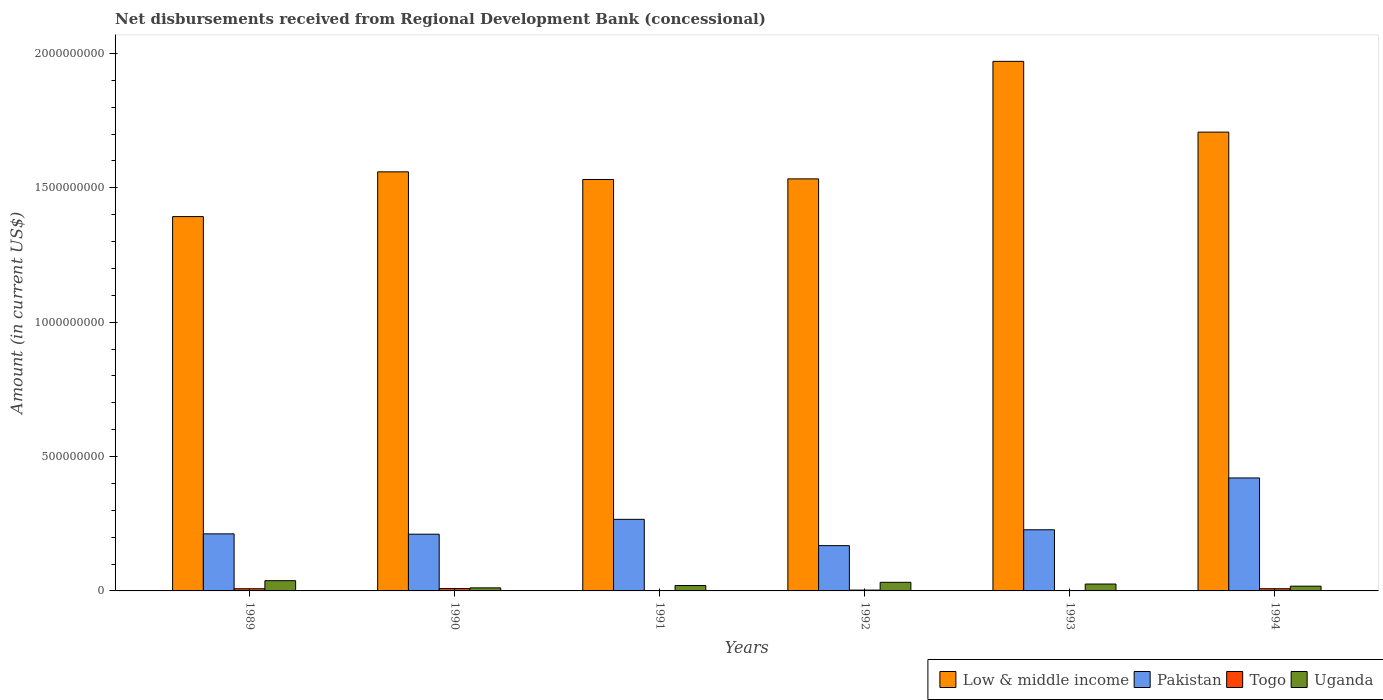How many different coloured bars are there?
Offer a terse response. 4. How many groups of bars are there?
Offer a terse response. 6. How many bars are there on the 2nd tick from the right?
Offer a very short reply. 4. What is the label of the 3rd group of bars from the left?
Offer a very short reply. 1991. In how many cases, is the number of bars for a given year not equal to the number of legend labels?
Keep it short and to the point. 0. What is the amount of disbursements received from Regional Development Bank in Togo in 1991?
Provide a succinct answer. 9.84e+05. Across all years, what is the maximum amount of disbursements received from Regional Development Bank in Uganda?
Ensure brevity in your answer.  3.81e+07. Across all years, what is the minimum amount of disbursements received from Regional Development Bank in Low & middle income?
Give a very brief answer. 1.39e+09. In which year was the amount of disbursements received from Regional Development Bank in Uganda minimum?
Your answer should be compact. 1990. What is the total amount of disbursements received from Regional Development Bank in Togo in the graph?
Provide a short and direct response. 2.90e+07. What is the difference between the amount of disbursements received from Regional Development Bank in Togo in 1989 and that in 1990?
Provide a succinct answer. -6.17e+05. What is the difference between the amount of disbursements received from Regional Development Bank in Low & middle income in 1994 and the amount of disbursements received from Regional Development Bank in Togo in 1990?
Keep it short and to the point. 1.70e+09. What is the average amount of disbursements received from Regional Development Bank in Togo per year?
Your answer should be compact. 4.84e+06. In the year 1989, what is the difference between the amount of disbursements received from Regional Development Bank in Togo and amount of disbursements received from Regional Development Bank in Uganda?
Your response must be concise. -3.01e+07. In how many years, is the amount of disbursements received from Regional Development Bank in Low & middle income greater than 1200000000 US$?
Your response must be concise. 6. What is the ratio of the amount of disbursements received from Regional Development Bank in Pakistan in 1989 to that in 1991?
Your answer should be very brief. 0.8. What is the difference between the highest and the second highest amount of disbursements received from Regional Development Bank in Uganda?
Make the answer very short. 6.10e+06. What is the difference between the highest and the lowest amount of disbursements received from Regional Development Bank in Pakistan?
Give a very brief answer. 2.52e+08. Is the sum of the amount of disbursements received from Regional Development Bank in Pakistan in 1989 and 1994 greater than the maximum amount of disbursements received from Regional Development Bank in Low & middle income across all years?
Give a very brief answer. No. Is it the case that in every year, the sum of the amount of disbursements received from Regional Development Bank in Togo and amount of disbursements received from Regional Development Bank in Pakistan is greater than the sum of amount of disbursements received from Regional Development Bank in Low & middle income and amount of disbursements received from Regional Development Bank in Uganda?
Give a very brief answer. Yes. What does the 4th bar from the right in 1993 represents?
Offer a terse response. Low & middle income. How many bars are there?
Keep it short and to the point. 24. How many years are there in the graph?
Offer a very short reply. 6. Does the graph contain any zero values?
Your response must be concise. No. Does the graph contain grids?
Offer a very short reply. No. How many legend labels are there?
Your response must be concise. 4. What is the title of the graph?
Offer a terse response. Net disbursements received from Regional Development Bank (concessional). Does "Greece" appear as one of the legend labels in the graph?
Your answer should be very brief. No. What is the label or title of the Y-axis?
Offer a very short reply. Amount (in current US$). What is the Amount (in current US$) in Low & middle income in 1989?
Your answer should be very brief. 1.39e+09. What is the Amount (in current US$) in Pakistan in 1989?
Keep it short and to the point. 2.12e+08. What is the Amount (in current US$) of Togo in 1989?
Make the answer very short. 8.07e+06. What is the Amount (in current US$) of Uganda in 1989?
Provide a short and direct response. 3.81e+07. What is the Amount (in current US$) in Low & middle income in 1990?
Keep it short and to the point. 1.56e+09. What is the Amount (in current US$) of Pakistan in 1990?
Offer a terse response. 2.11e+08. What is the Amount (in current US$) in Togo in 1990?
Your response must be concise. 8.69e+06. What is the Amount (in current US$) in Uganda in 1990?
Offer a very short reply. 1.14e+07. What is the Amount (in current US$) in Low & middle income in 1991?
Offer a terse response. 1.53e+09. What is the Amount (in current US$) of Pakistan in 1991?
Ensure brevity in your answer.  2.66e+08. What is the Amount (in current US$) of Togo in 1991?
Your answer should be very brief. 9.84e+05. What is the Amount (in current US$) of Uganda in 1991?
Give a very brief answer. 2.01e+07. What is the Amount (in current US$) of Low & middle income in 1992?
Make the answer very short. 1.53e+09. What is the Amount (in current US$) in Pakistan in 1992?
Your answer should be very brief. 1.69e+08. What is the Amount (in current US$) of Togo in 1992?
Your answer should be compact. 3.04e+06. What is the Amount (in current US$) in Uganda in 1992?
Give a very brief answer. 3.20e+07. What is the Amount (in current US$) of Low & middle income in 1993?
Provide a succinct answer. 1.97e+09. What is the Amount (in current US$) in Pakistan in 1993?
Your response must be concise. 2.28e+08. What is the Amount (in current US$) in Togo in 1993?
Your response must be concise. 8.80e+04. What is the Amount (in current US$) in Uganda in 1993?
Your answer should be compact. 2.56e+07. What is the Amount (in current US$) of Low & middle income in 1994?
Give a very brief answer. 1.71e+09. What is the Amount (in current US$) in Pakistan in 1994?
Make the answer very short. 4.20e+08. What is the Amount (in current US$) of Togo in 1994?
Provide a short and direct response. 8.16e+06. What is the Amount (in current US$) in Uganda in 1994?
Your answer should be very brief. 1.77e+07. Across all years, what is the maximum Amount (in current US$) in Low & middle income?
Provide a succinct answer. 1.97e+09. Across all years, what is the maximum Amount (in current US$) in Pakistan?
Ensure brevity in your answer.  4.20e+08. Across all years, what is the maximum Amount (in current US$) in Togo?
Your answer should be very brief. 8.69e+06. Across all years, what is the maximum Amount (in current US$) of Uganda?
Your answer should be compact. 3.81e+07. Across all years, what is the minimum Amount (in current US$) in Low & middle income?
Ensure brevity in your answer.  1.39e+09. Across all years, what is the minimum Amount (in current US$) of Pakistan?
Give a very brief answer. 1.69e+08. Across all years, what is the minimum Amount (in current US$) in Togo?
Your answer should be compact. 8.80e+04. Across all years, what is the minimum Amount (in current US$) of Uganda?
Give a very brief answer. 1.14e+07. What is the total Amount (in current US$) in Low & middle income in the graph?
Provide a short and direct response. 9.70e+09. What is the total Amount (in current US$) of Pakistan in the graph?
Provide a short and direct response. 1.51e+09. What is the total Amount (in current US$) in Togo in the graph?
Offer a very short reply. 2.90e+07. What is the total Amount (in current US$) of Uganda in the graph?
Offer a very short reply. 1.45e+08. What is the difference between the Amount (in current US$) of Low & middle income in 1989 and that in 1990?
Your answer should be compact. -1.67e+08. What is the difference between the Amount (in current US$) of Pakistan in 1989 and that in 1990?
Offer a terse response. 1.24e+06. What is the difference between the Amount (in current US$) of Togo in 1989 and that in 1990?
Give a very brief answer. -6.17e+05. What is the difference between the Amount (in current US$) of Uganda in 1989 and that in 1990?
Provide a succinct answer. 2.67e+07. What is the difference between the Amount (in current US$) in Low & middle income in 1989 and that in 1991?
Offer a terse response. -1.38e+08. What is the difference between the Amount (in current US$) in Pakistan in 1989 and that in 1991?
Your answer should be compact. -5.40e+07. What is the difference between the Amount (in current US$) of Togo in 1989 and that in 1991?
Provide a short and direct response. 7.09e+06. What is the difference between the Amount (in current US$) in Uganda in 1989 and that in 1991?
Ensure brevity in your answer.  1.81e+07. What is the difference between the Amount (in current US$) of Low & middle income in 1989 and that in 1992?
Your answer should be very brief. -1.40e+08. What is the difference between the Amount (in current US$) in Pakistan in 1989 and that in 1992?
Give a very brief answer. 4.38e+07. What is the difference between the Amount (in current US$) of Togo in 1989 and that in 1992?
Offer a terse response. 5.04e+06. What is the difference between the Amount (in current US$) of Uganda in 1989 and that in 1992?
Your answer should be very brief. 6.10e+06. What is the difference between the Amount (in current US$) of Low & middle income in 1989 and that in 1993?
Give a very brief answer. -5.78e+08. What is the difference between the Amount (in current US$) of Pakistan in 1989 and that in 1993?
Your answer should be compact. -1.52e+07. What is the difference between the Amount (in current US$) in Togo in 1989 and that in 1993?
Provide a succinct answer. 7.99e+06. What is the difference between the Amount (in current US$) in Uganda in 1989 and that in 1993?
Ensure brevity in your answer.  1.25e+07. What is the difference between the Amount (in current US$) of Low & middle income in 1989 and that in 1994?
Offer a very short reply. -3.14e+08. What is the difference between the Amount (in current US$) in Pakistan in 1989 and that in 1994?
Offer a terse response. -2.08e+08. What is the difference between the Amount (in current US$) in Togo in 1989 and that in 1994?
Give a very brief answer. -8.70e+04. What is the difference between the Amount (in current US$) of Uganda in 1989 and that in 1994?
Your response must be concise. 2.04e+07. What is the difference between the Amount (in current US$) in Low & middle income in 1990 and that in 1991?
Make the answer very short. 2.84e+07. What is the difference between the Amount (in current US$) of Pakistan in 1990 and that in 1991?
Offer a very short reply. -5.53e+07. What is the difference between the Amount (in current US$) of Togo in 1990 and that in 1991?
Give a very brief answer. 7.71e+06. What is the difference between the Amount (in current US$) of Uganda in 1990 and that in 1991?
Your answer should be compact. -8.68e+06. What is the difference between the Amount (in current US$) in Low & middle income in 1990 and that in 1992?
Provide a short and direct response. 2.62e+07. What is the difference between the Amount (in current US$) of Pakistan in 1990 and that in 1992?
Give a very brief answer. 4.26e+07. What is the difference between the Amount (in current US$) in Togo in 1990 and that in 1992?
Your answer should be compact. 5.66e+06. What is the difference between the Amount (in current US$) in Uganda in 1990 and that in 1992?
Make the answer very short. -2.06e+07. What is the difference between the Amount (in current US$) in Low & middle income in 1990 and that in 1993?
Your response must be concise. -4.11e+08. What is the difference between the Amount (in current US$) in Pakistan in 1990 and that in 1993?
Your response must be concise. -1.65e+07. What is the difference between the Amount (in current US$) of Togo in 1990 and that in 1993?
Ensure brevity in your answer.  8.60e+06. What is the difference between the Amount (in current US$) in Uganda in 1990 and that in 1993?
Keep it short and to the point. -1.42e+07. What is the difference between the Amount (in current US$) of Low & middle income in 1990 and that in 1994?
Your answer should be compact. -1.48e+08. What is the difference between the Amount (in current US$) in Pakistan in 1990 and that in 1994?
Offer a terse response. -2.09e+08. What is the difference between the Amount (in current US$) in Togo in 1990 and that in 1994?
Offer a very short reply. 5.30e+05. What is the difference between the Amount (in current US$) of Uganda in 1990 and that in 1994?
Ensure brevity in your answer.  -6.33e+06. What is the difference between the Amount (in current US$) in Low & middle income in 1991 and that in 1992?
Ensure brevity in your answer.  -2.18e+06. What is the difference between the Amount (in current US$) of Pakistan in 1991 and that in 1992?
Offer a terse response. 9.79e+07. What is the difference between the Amount (in current US$) in Togo in 1991 and that in 1992?
Your answer should be compact. -2.05e+06. What is the difference between the Amount (in current US$) of Uganda in 1991 and that in 1992?
Offer a very short reply. -1.20e+07. What is the difference between the Amount (in current US$) in Low & middle income in 1991 and that in 1993?
Make the answer very short. -4.40e+08. What is the difference between the Amount (in current US$) in Pakistan in 1991 and that in 1993?
Your answer should be compact. 3.88e+07. What is the difference between the Amount (in current US$) of Togo in 1991 and that in 1993?
Your response must be concise. 8.96e+05. What is the difference between the Amount (in current US$) in Uganda in 1991 and that in 1993?
Provide a succinct answer. -5.54e+06. What is the difference between the Amount (in current US$) of Low & middle income in 1991 and that in 1994?
Your answer should be very brief. -1.76e+08. What is the difference between the Amount (in current US$) in Pakistan in 1991 and that in 1994?
Provide a short and direct response. -1.54e+08. What is the difference between the Amount (in current US$) of Togo in 1991 and that in 1994?
Your answer should be very brief. -7.18e+06. What is the difference between the Amount (in current US$) of Uganda in 1991 and that in 1994?
Your answer should be compact. 2.36e+06. What is the difference between the Amount (in current US$) in Low & middle income in 1992 and that in 1993?
Offer a terse response. -4.37e+08. What is the difference between the Amount (in current US$) of Pakistan in 1992 and that in 1993?
Your response must be concise. -5.91e+07. What is the difference between the Amount (in current US$) in Togo in 1992 and that in 1993?
Ensure brevity in your answer.  2.95e+06. What is the difference between the Amount (in current US$) in Uganda in 1992 and that in 1993?
Offer a very short reply. 6.41e+06. What is the difference between the Amount (in current US$) in Low & middle income in 1992 and that in 1994?
Provide a short and direct response. -1.74e+08. What is the difference between the Amount (in current US$) of Pakistan in 1992 and that in 1994?
Give a very brief answer. -2.52e+08. What is the difference between the Amount (in current US$) of Togo in 1992 and that in 1994?
Your response must be concise. -5.13e+06. What is the difference between the Amount (in current US$) in Uganda in 1992 and that in 1994?
Your answer should be very brief. 1.43e+07. What is the difference between the Amount (in current US$) in Low & middle income in 1993 and that in 1994?
Provide a short and direct response. 2.63e+08. What is the difference between the Amount (in current US$) in Pakistan in 1993 and that in 1994?
Provide a succinct answer. -1.93e+08. What is the difference between the Amount (in current US$) of Togo in 1993 and that in 1994?
Provide a succinct answer. -8.07e+06. What is the difference between the Amount (in current US$) in Uganda in 1993 and that in 1994?
Your answer should be compact. 7.90e+06. What is the difference between the Amount (in current US$) of Low & middle income in 1989 and the Amount (in current US$) of Pakistan in 1990?
Keep it short and to the point. 1.18e+09. What is the difference between the Amount (in current US$) in Low & middle income in 1989 and the Amount (in current US$) in Togo in 1990?
Give a very brief answer. 1.38e+09. What is the difference between the Amount (in current US$) in Low & middle income in 1989 and the Amount (in current US$) in Uganda in 1990?
Give a very brief answer. 1.38e+09. What is the difference between the Amount (in current US$) in Pakistan in 1989 and the Amount (in current US$) in Togo in 1990?
Your answer should be very brief. 2.04e+08. What is the difference between the Amount (in current US$) of Pakistan in 1989 and the Amount (in current US$) of Uganda in 1990?
Give a very brief answer. 2.01e+08. What is the difference between the Amount (in current US$) in Togo in 1989 and the Amount (in current US$) in Uganda in 1990?
Offer a terse response. -3.32e+06. What is the difference between the Amount (in current US$) in Low & middle income in 1989 and the Amount (in current US$) in Pakistan in 1991?
Offer a very short reply. 1.13e+09. What is the difference between the Amount (in current US$) in Low & middle income in 1989 and the Amount (in current US$) in Togo in 1991?
Ensure brevity in your answer.  1.39e+09. What is the difference between the Amount (in current US$) in Low & middle income in 1989 and the Amount (in current US$) in Uganda in 1991?
Ensure brevity in your answer.  1.37e+09. What is the difference between the Amount (in current US$) of Pakistan in 1989 and the Amount (in current US$) of Togo in 1991?
Ensure brevity in your answer.  2.11e+08. What is the difference between the Amount (in current US$) in Pakistan in 1989 and the Amount (in current US$) in Uganda in 1991?
Provide a succinct answer. 1.92e+08. What is the difference between the Amount (in current US$) of Togo in 1989 and the Amount (in current US$) of Uganda in 1991?
Offer a very short reply. -1.20e+07. What is the difference between the Amount (in current US$) in Low & middle income in 1989 and the Amount (in current US$) in Pakistan in 1992?
Offer a very short reply. 1.22e+09. What is the difference between the Amount (in current US$) in Low & middle income in 1989 and the Amount (in current US$) in Togo in 1992?
Offer a terse response. 1.39e+09. What is the difference between the Amount (in current US$) in Low & middle income in 1989 and the Amount (in current US$) in Uganda in 1992?
Your answer should be compact. 1.36e+09. What is the difference between the Amount (in current US$) of Pakistan in 1989 and the Amount (in current US$) of Togo in 1992?
Your response must be concise. 2.09e+08. What is the difference between the Amount (in current US$) of Pakistan in 1989 and the Amount (in current US$) of Uganda in 1992?
Make the answer very short. 1.80e+08. What is the difference between the Amount (in current US$) in Togo in 1989 and the Amount (in current US$) in Uganda in 1992?
Keep it short and to the point. -2.40e+07. What is the difference between the Amount (in current US$) in Low & middle income in 1989 and the Amount (in current US$) in Pakistan in 1993?
Keep it short and to the point. 1.17e+09. What is the difference between the Amount (in current US$) in Low & middle income in 1989 and the Amount (in current US$) in Togo in 1993?
Your answer should be very brief. 1.39e+09. What is the difference between the Amount (in current US$) of Low & middle income in 1989 and the Amount (in current US$) of Uganda in 1993?
Provide a short and direct response. 1.37e+09. What is the difference between the Amount (in current US$) in Pakistan in 1989 and the Amount (in current US$) in Togo in 1993?
Give a very brief answer. 2.12e+08. What is the difference between the Amount (in current US$) in Pakistan in 1989 and the Amount (in current US$) in Uganda in 1993?
Make the answer very short. 1.87e+08. What is the difference between the Amount (in current US$) in Togo in 1989 and the Amount (in current US$) in Uganda in 1993?
Keep it short and to the point. -1.75e+07. What is the difference between the Amount (in current US$) in Low & middle income in 1989 and the Amount (in current US$) in Pakistan in 1994?
Provide a short and direct response. 9.73e+08. What is the difference between the Amount (in current US$) of Low & middle income in 1989 and the Amount (in current US$) of Togo in 1994?
Offer a terse response. 1.38e+09. What is the difference between the Amount (in current US$) of Low & middle income in 1989 and the Amount (in current US$) of Uganda in 1994?
Your answer should be compact. 1.38e+09. What is the difference between the Amount (in current US$) of Pakistan in 1989 and the Amount (in current US$) of Togo in 1994?
Give a very brief answer. 2.04e+08. What is the difference between the Amount (in current US$) of Pakistan in 1989 and the Amount (in current US$) of Uganda in 1994?
Offer a terse response. 1.95e+08. What is the difference between the Amount (in current US$) in Togo in 1989 and the Amount (in current US$) in Uganda in 1994?
Make the answer very short. -9.64e+06. What is the difference between the Amount (in current US$) in Low & middle income in 1990 and the Amount (in current US$) in Pakistan in 1991?
Give a very brief answer. 1.29e+09. What is the difference between the Amount (in current US$) in Low & middle income in 1990 and the Amount (in current US$) in Togo in 1991?
Provide a succinct answer. 1.56e+09. What is the difference between the Amount (in current US$) of Low & middle income in 1990 and the Amount (in current US$) of Uganda in 1991?
Offer a very short reply. 1.54e+09. What is the difference between the Amount (in current US$) of Pakistan in 1990 and the Amount (in current US$) of Togo in 1991?
Provide a short and direct response. 2.10e+08. What is the difference between the Amount (in current US$) in Pakistan in 1990 and the Amount (in current US$) in Uganda in 1991?
Keep it short and to the point. 1.91e+08. What is the difference between the Amount (in current US$) in Togo in 1990 and the Amount (in current US$) in Uganda in 1991?
Your answer should be compact. -1.14e+07. What is the difference between the Amount (in current US$) of Low & middle income in 1990 and the Amount (in current US$) of Pakistan in 1992?
Offer a terse response. 1.39e+09. What is the difference between the Amount (in current US$) in Low & middle income in 1990 and the Amount (in current US$) in Togo in 1992?
Keep it short and to the point. 1.56e+09. What is the difference between the Amount (in current US$) of Low & middle income in 1990 and the Amount (in current US$) of Uganda in 1992?
Give a very brief answer. 1.53e+09. What is the difference between the Amount (in current US$) in Pakistan in 1990 and the Amount (in current US$) in Togo in 1992?
Offer a terse response. 2.08e+08. What is the difference between the Amount (in current US$) of Pakistan in 1990 and the Amount (in current US$) of Uganda in 1992?
Offer a very short reply. 1.79e+08. What is the difference between the Amount (in current US$) of Togo in 1990 and the Amount (in current US$) of Uganda in 1992?
Your answer should be very brief. -2.33e+07. What is the difference between the Amount (in current US$) in Low & middle income in 1990 and the Amount (in current US$) in Pakistan in 1993?
Your response must be concise. 1.33e+09. What is the difference between the Amount (in current US$) of Low & middle income in 1990 and the Amount (in current US$) of Togo in 1993?
Provide a succinct answer. 1.56e+09. What is the difference between the Amount (in current US$) in Low & middle income in 1990 and the Amount (in current US$) in Uganda in 1993?
Your answer should be compact. 1.53e+09. What is the difference between the Amount (in current US$) in Pakistan in 1990 and the Amount (in current US$) in Togo in 1993?
Keep it short and to the point. 2.11e+08. What is the difference between the Amount (in current US$) in Pakistan in 1990 and the Amount (in current US$) in Uganda in 1993?
Your answer should be compact. 1.86e+08. What is the difference between the Amount (in current US$) of Togo in 1990 and the Amount (in current US$) of Uganda in 1993?
Offer a very short reply. -1.69e+07. What is the difference between the Amount (in current US$) in Low & middle income in 1990 and the Amount (in current US$) in Pakistan in 1994?
Offer a very short reply. 1.14e+09. What is the difference between the Amount (in current US$) in Low & middle income in 1990 and the Amount (in current US$) in Togo in 1994?
Your answer should be compact. 1.55e+09. What is the difference between the Amount (in current US$) in Low & middle income in 1990 and the Amount (in current US$) in Uganda in 1994?
Your answer should be very brief. 1.54e+09. What is the difference between the Amount (in current US$) in Pakistan in 1990 and the Amount (in current US$) in Togo in 1994?
Give a very brief answer. 2.03e+08. What is the difference between the Amount (in current US$) in Pakistan in 1990 and the Amount (in current US$) in Uganda in 1994?
Ensure brevity in your answer.  1.93e+08. What is the difference between the Amount (in current US$) in Togo in 1990 and the Amount (in current US$) in Uganda in 1994?
Keep it short and to the point. -9.02e+06. What is the difference between the Amount (in current US$) of Low & middle income in 1991 and the Amount (in current US$) of Pakistan in 1992?
Keep it short and to the point. 1.36e+09. What is the difference between the Amount (in current US$) in Low & middle income in 1991 and the Amount (in current US$) in Togo in 1992?
Your answer should be compact. 1.53e+09. What is the difference between the Amount (in current US$) of Low & middle income in 1991 and the Amount (in current US$) of Uganda in 1992?
Your answer should be compact. 1.50e+09. What is the difference between the Amount (in current US$) in Pakistan in 1991 and the Amount (in current US$) in Togo in 1992?
Provide a succinct answer. 2.63e+08. What is the difference between the Amount (in current US$) in Pakistan in 1991 and the Amount (in current US$) in Uganda in 1992?
Offer a very short reply. 2.34e+08. What is the difference between the Amount (in current US$) of Togo in 1991 and the Amount (in current US$) of Uganda in 1992?
Your response must be concise. -3.10e+07. What is the difference between the Amount (in current US$) of Low & middle income in 1991 and the Amount (in current US$) of Pakistan in 1993?
Your answer should be compact. 1.30e+09. What is the difference between the Amount (in current US$) in Low & middle income in 1991 and the Amount (in current US$) in Togo in 1993?
Offer a very short reply. 1.53e+09. What is the difference between the Amount (in current US$) of Low & middle income in 1991 and the Amount (in current US$) of Uganda in 1993?
Ensure brevity in your answer.  1.51e+09. What is the difference between the Amount (in current US$) in Pakistan in 1991 and the Amount (in current US$) in Togo in 1993?
Provide a short and direct response. 2.66e+08. What is the difference between the Amount (in current US$) of Pakistan in 1991 and the Amount (in current US$) of Uganda in 1993?
Ensure brevity in your answer.  2.41e+08. What is the difference between the Amount (in current US$) of Togo in 1991 and the Amount (in current US$) of Uganda in 1993?
Offer a terse response. -2.46e+07. What is the difference between the Amount (in current US$) of Low & middle income in 1991 and the Amount (in current US$) of Pakistan in 1994?
Give a very brief answer. 1.11e+09. What is the difference between the Amount (in current US$) in Low & middle income in 1991 and the Amount (in current US$) in Togo in 1994?
Offer a terse response. 1.52e+09. What is the difference between the Amount (in current US$) in Low & middle income in 1991 and the Amount (in current US$) in Uganda in 1994?
Provide a succinct answer. 1.51e+09. What is the difference between the Amount (in current US$) of Pakistan in 1991 and the Amount (in current US$) of Togo in 1994?
Provide a succinct answer. 2.58e+08. What is the difference between the Amount (in current US$) in Pakistan in 1991 and the Amount (in current US$) in Uganda in 1994?
Offer a terse response. 2.49e+08. What is the difference between the Amount (in current US$) of Togo in 1991 and the Amount (in current US$) of Uganda in 1994?
Provide a succinct answer. -1.67e+07. What is the difference between the Amount (in current US$) in Low & middle income in 1992 and the Amount (in current US$) in Pakistan in 1993?
Your response must be concise. 1.31e+09. What is the difference between the Amount (in current US$) of Low & middle income in 1992 and the Amount (in current US$) of Togo in 1993?
Your answer should be very brief. 1.53e+09. What is the difference between the Amount (in current US$) in Low & middle income in 1992 and the Amount (in current US$) in Uganda in 1993?
Keep it short and to the point. 1.51e+09. What is the difference between the Amount (in current US$) in Pakistan in 1992 and the Amount (in current US$) in Togo in 1993?
Provide a short and direct response. 1.68e+08. What is the difference between the Amount (in current US$) in Pakistan in 1992 and the Amount (in current US$) in Uganda in 1993?
Provide a short and direct response. 1.43e+08. What is the difference between the Amount (in current US$) of Togo in 1992 and the Amount (in current US$) of Uganda in 1993?
Your response must be concise. -2.26e+07. What is the difference between the Amount (in current US$) in Low & middle income in 1992 and the Amount (in current US$) in Pakistan in 1994?
Your answer should be compact. 1.11e+09. What is the difference between the Amount (in current US$) of Low & middle income in 1992 and the Amount (in current US$) of Togo in 1994?
Your response must be concise. 1.53e+09. What is the difference between the Amount (in current US$) of Low & middle income in 1992 and the Amount (in current US$) of Uganda in 1994?
Your answer should be compact. 1.52e+09. What is the difference between the Amount (in current US$) in Pakistan in 1992 and the Amount (in current US$) in Togo in 1994?
Provide a succinct answer. 1.60e+08. What is the difference between the Amount (in current US$) of Pakistan in 1992 and the Amount (in current US$) of Uganda in 1994?
Ensure brevity in your answer.  1.51e+08. What is the difference between the Amount (in current US$) in Togo in 1992 and the Amount (in current US$) in Uganda in 1994?
Give a very brief answer. -1.47e+07. What is the difference between the Amount (in current US$) of Low & middle income in 1993 and the Amount (in current US$) of Pakistan in 1994?
Give a very brief answer. 1.55e+09. What is the difference between the Amount (in current US$) of Low & middle income in 1993 and the Amount (in current US$) of Togo in 1994?
Provide a succinct answer. 1.96e+09. What is the difference between the Amount (in current US$) of Low & middle income in 1993 and the Amount (in current US$) of Uganda in 1994?
Offer a terse response. 1.95e+09. What is the difference between the Amount (in current US$) in Pakistan in 1993 and the Amount (in current US$) in Togo in 1994?
Give a very brief answer. 2.19e+08. What is the difference between the Amount (in current US$) in Pakistan in 1993 and the Amount (in current US$) in Uganda in 1994?
Your response must be concise. 2.10e+08. What is the difference between the Amount (in current US$) of Togo in 1993 and the Amount (in current US$) of Uganda in 1994?
Ensure brevity in your answer.  -1.76e+07. What is the average Amount (in current US$) in Low & middle income per year?
Ensure brevity in your answer.  1.62e+09. What is the average Amount (in current US$) of Pakistan per year?
Offer a terse response. 2.51e+08. What is the average Amount (in current US$) of Togo per year?
Your response must be concise. 4.84e+06. What is the average Amount (in current US$) in Uganda per year?
Your response must be concise. 2.42e+07. In the year 1989, what is the difference between the Amount (in current US$) of Low & middle income and Amount (in current US$) of Pakistan?
Your response must be concise. 1.18e+09. In the year 1989, what is the difference between the Amount (in current US$) of Low & middle income and Amount (in current US$) of Togo?
Provide a succinct answer. 1.39e+09. In the year 1989, what is the difference between the Amount (in current US$) of Low & middle income and Amount (in current US$) of Uganda?
Make the answer very short. 1.35e+09. In the year 1989, what is the difference between the Amount (in current US$) in Pakistan and Amount (in current US$) in Togo?
Your answer should be very brief. 2.04e+08. In the year 1989, what is the difference between the Amount (in current US$) of Pakistan and Amount (in current US$) of Uganda?
Keep it short and to the point. 1.74e+08. In the year 1989, what is the difference between the Amount (in current US$) in Togo and Amount (in current US$) in Uganda?
Give a very brief answer. -3.01e+07. In the year 1990, what is the difference between the Amount (in current US$) of Low & middle income and Amount (in current US$) of Pakistan?
Make the answer very short. 1.35e+09. In the year 1990, what is the difference between the Amount (in current US$) of Low & middle income and Amount (in current US$) of Togo?
Make the answer very short. 1.55e+09. In the year 1990, what is the difference between the Amount (in current US$) in Low & middle income and Amount (in current US$) in Uganda?
Your answer should be very brief. 1.55e+09. In the year 1990, what is the difference between the Amount (in current US$) of Pakistan and Amount (in current US$) of Togo?
Provide a short and direct response. 2.02e+08. In the year 1990, what is the difference between the Amount (in current US$) of Pakistan and Amount (in current US$) of Uganda?
Keep it short and to the point. 2.00e+08. In the year 1990, what is the difference between the Amount (in current US$) of Togo and Amount (in current US$) of Uganda?
Give a very brief answer. -2.70e+06. In the year 1991, what is the difference between the Amount (in current US$) in Low & middle income and Amount (in current US$) in Pakistan?
Your answer should be very brief. 1.26e+09. In the year 1991, what is the difference between the Amount (in current US$) of Low & middle income and Amount (in current US$) of Togo?
Offer a very short reply. 1.53e+09. In the year 1991, what is the difference between the Amount (in current US$) in Low & middle income and Amount (in current US$) in Uganda?
Offer a terse response. 1.51e+09. In the year 1991, what is the difference between the Amount (in current US$) in Pakistan and Amount (in current US$) in Togo?
Ensure brevity in your answer.  2.65e+08. In the year 1991, what is the difference between the Amount (in current US$) of Pakistan and Amount (in current US$) of Uganda?
Provide a short and direct response. 2.46e+08. In the year 1991, what is the difference between the Amount (in current US$) of Togo and Amount (in current US$) of Uganda?
Keep it short and to the point. -1.91e+07. In the year 1992, what is the difference between the Amount (in current US$) in Low & middle income and Amount (in current US$) in Pakistan?
Make the answer very short. 1.36e+09. In the year 1992, what is the difference between the Amount (in current US$) of Low & middle income and Amount (in current US$) of Togo?
Your answer should be compact. 1.53e+09. In the year 1992, what is the difference between the Amount (in current US$) of Low & middle income and Amount (in current US$) of Uganda?
Provide a succinct answer. 1.50e+09. In the year 1992, what is the difference between the Amount (in current US$) of Pakistan and Amount (in current US$) of Togo?
Offer a very short reply. 1.65e+08. In the year 1992, what is the difference between the Amount (in current US$) in Pakistan and Amount (in current US$) in Uganda?
Offer a terse response. 1.36e+08. In the year 1992, what is the difference between the Amount (in current US$) of Togo and Amount (in current US$) of Uganda?
Make the answer very short. -2.90e+07. In the year 1993, what is the difference between the Amount (in current US$) of Low & middle income and Amount (in current US$) of Pakistan?
Offer a very short reply. 1.74e+09. In the year 1993, what is the difference between the Amount (in current US$) in Low & middle income and Amount (in current US$) in Togo?
Your answer should be compact. 1.97e+09. In the year 1993, what is the difference between the Amount (in current US$) in Low & middle income and Amount (in current US$) in Uganda?
Provide a short and direct response. 1.95e+09. In the year 1993, what is the difference between the Amount (in current US$) of Pakistan and Amount (in current US$) of Togo?
Offer a very short reply. 2.27e+08. In the year 1993, what is the difference between the Amount (in current US$) of Pakistan and Amount (in current US$) of Uganda?
Offer a terse response. 2.02e+08. In the year 1993, what is the difference between the Amount (in current US$) in Togo and Amount (in current US$) in Uganda?
Your answer should be very brief. -2.55e+07. In the year 1994, what is the difference between the Amount (in current US$) of Low & middle income and Amount (in current US$) of Pakistan?
Your response must be concise. 1.29e+09. In the year 1994, what is the difference between the Amount (in current US$) in Low & middle income and Amount (in current US$) in Togo?
Your response must be concise. 1.70e+09. In the year 1994, what is the difference between the Amount (in current US$) in Low & middle income and Amount (in current US$) in Uganda?
Provide a short and direct response. 1.69e+09. In the year 1994, what is the difference between the Amount (in current US$) of Pakistan and Amount (in current US$) of Togo?
Make the answer very short. 4.12e+08. In the year 1994, what is the difference between the Amount (in current US$) in Pakistan and Amount (in current US$) in Uganda?
Give a very brief answer. 4.03e+08. In the year 1994, what is the difference between the Amount (in current US$) of Togo and Amount (in current US$) of Uganda?
Ensure brevity in your answer.  -9.56e+06. What is the ratio of the Amount (in current US$) in Low & middle income in 1989 to that in 1990?
Provide a succinct answer. 0.89. What is the ratio of the Amount (in current US$) of Pakistan in 1989 to that in 1990?
Offer a terse response. 1.01. What is the ratio of the Amount (in current US$) of Togo in 1989 to that in 1990?
Keep it short and to the point. 0.93. What is the ratio of the Amount (in current US$) in Uganda in 1989 to that in 1990?
Provide a succinct answer. 3.35. What is the ratio of the Amount (in current US$) of Low & middle income in 1989 to that in 1991?
Give a very brief answer. 0.91. What is the ratio of the Amount (in current US$) of Pakistan in 1989 to that in 1991?
Provide a short and direct response. 0.8. What is the ratio of the Amount (in current US$) of Togo in 1989 to that in 1991?
Give a very brief answer. 8.21. What is the ratio of the Amount (in current US$) in Uganda in 1989 to that in 1991?
Your answer should be very brief. 1.9. What is the ratio of the Amount (in current US$) of Low & middle income in 1989 to that in 1992?
Offer a very short reply. 0.91. What is the ratio of the Amount (in current US$) in Pakistan in 1989 to that in 1992?
Offer a terse response. 1.26. What is the ratio of the Amount (in current US$) in Togo in 1989 to that in 1992?
Keep it short and to the point. 2.66. What is the ratio of the Amount (in current US$) in Uganda in 1989 to that in 1992?
Give a very brief answer. 1.19. What is the ratio of the Amount (in current US$) of Low & middle income in 1989 to that in 1993?
Give a very brief answer. 0.71. What is the ratio of the Amount (in current US$) in Pakistan in 1989 to that in 1993?
Make the answer very short. 0.93. What is the ratio of the Amount (in current US$) in Togo in 1989 to that in 1993?
Offer a very short reply. 91.75. What is the ratio of the Amount (in current US$) in Uganda in 1989 to that in 1993?
Give a very brief answer. 1.49. What is the ratio of the Amount (in current US$) in Low & middle income in 1989 to that in 1994?
Offer a very short reply. 0.82. What is the ratio of the Amount (in current US$) in Pakistan in 1989 to that in 1994?
Provide a short and direct response. 0.51. What is the ratio of the Amount (in current US$) in Togo in 1989 to that in 1994?
Offer a very short reply. 0.99. What is the ratio of the Amount (in current US$) in Uganda in 1989 to that in 1994?
Your answer should be compact. 2.15. What is the ratio of the Amount (in current US$) of Low & middle income in 1990 to that in 1991?
Ensure brevity in your answer.  1.02. What is the ratio of the Amount (in current US$) in Pakistan in 1990 to that in 1991?
Your response must be concise. 0.79. What is the ratio of the Amount (in current US$) of Togo in 1990 to that in 1991?
Offer a very short reply. 8.83. What is the ratio of the Amount (in current US$) in Uganda in 1990 to that in 1991?
Make the answer very short. 0.57. What is the ratio of the Amount (in current US$) in Low & middle income in 1990 to that in 1992?
Your answer should be very brief. 1.02. What is the ratio of the Amount (in current US$) of Pakistan in 1990 to that in 1992?
Offer a terse response. 1.25. What is the ratio of the Amount (in current US$) in Togo in 1990 to that in 1992?
Provide a succinct answer. 2.86. What is the ratio of the Amount (in current US$) in Uganda in 1990 to that in 1992?
Ensure brevity in your answer.  0.36. What is the ratio of the Amount (in current US$) in Low & middle income in 1990 to that in 1993?
Provide a short and direct response. 0.79. What is the ratio of the Amount (in current US$) of Pakistan in 1990 to that in 1993?
Make the answer very short. 0.93. What is the ratio of the Amount (in current US$) of Togo in 1990 to that in 1993?
Provide a short and direct response. 98.76. What is the ratio of the Amount (in current US$) of Uganda in 1990 to that in 1993?
Your answer should be compact. 0.44. What is the ratio of the Amount (in current US$) in Low & middle income in 1990 to that in 1994?
Your answer should be compact. 0.91. What is the ratio of the Amount (in current US$) in Pakistan in 1990 to that in 1994?
Offer a very short reply. 0.5. What is the ratio of the Amount (in current US$) of Togo in 1990 to that in 1994?
Provide a succinct answer. 1.06. What is the ratio of the Amount (in current US$) of Uganda in 1990 to that in 1994?
Keep it short and to the point. 0.64. What is the ratio of the Amount (in current US$) of Low & middle income in 1991 to that in 1992?
Make the answer very short. 1. What is the ratio of the Amount (in current US$) in Pakistan in 1991 to that in 1992?
Your answer should be compact. 1.58. What is the ratio of the Amount (in current US$) in Togo in 1991 to that in 1992?
Offer a very short reply. 0.32. What is the ratio of the Amount (in current US$) of Uganda in 1991 to that in 1992?
Your response must be concise. 0.63. What is the ratio of the Amount (in current US$) of Low & middle income in 1991 to that in 1993?
Your response must be concise. 0.78. What is the ratio of the Amount (in current US$) in Pakistan in 1991 to that in 1993?
Ensure brevity in your answer.  1.17. What is the ratio of the Amount (in current US$) of Togo in 1991 to that in 1993?
Your answer should be very brief. 11.18. What is the ratio of the Amount (in current US$) of Uganda in 1991 to that in 1993?
Your response must be concise. 0.78. What is the ratio of the Amount (in current US$) in Low & middle income in 1991 to that in 1994?
Provide a succinct answer. 0.9. What is the ratio of the Amount (in current US$) in Pakistan in 1991 to that in 1994?
Provide a short and direct response. 0.63. What is the ratio of the Amount (in current US$) of Togo in 1991 to that in 1994?
Provide a succinct answer. 0.12. What is the ratio of the Amount (in current US$) in Uganda in 1991 to that in 1994?
Your answer should be compact. 1.13. What is the ratio of the Amount (in current US$) in Low & middle income in 1992 to that in 1993?
Ensure brevity in your answer.  0.78. What is the ratio of the Amount (in current US$) in Pakistan in 1992 to that in 1993?
Your response must be concise. 0.74. What is the ratio of the Amount (in current US$) of Togo in 1992 to that in 1993?
Provide a short and direct response. 34.49. What is the ratio of the Amount (in current US$) in Uganda in 1992 to that in 1993?
Provide a short and direct response. 1.25. What is the ratio of the Amount (in current US$) in Low & middle income in 1992 to that in 1994?
Your answer should be compact. 0.9. What is the ratio of the Amount (in current US$) in Pakistan in 1992 to that in 1994?
Keep it short and to the point. 0.4. What is the ratio of the Amount (in current US$) of Togo in 1992 to that in 1994?
Your answer should be compact. 0.37. What is the ratio of the Amount (in current US$) in Uganda in 1992 to that in 1994?
Your answer should be compact. 1.81. What is the ratio of the Amount (in current US$) in Low & middle income in 1993 to that in 1994?
Your answer should be very brief. 1.15. What is the ratio of the Amount (in current US$) in Pakistan in 1993 to that in 1994?
Provide a succinct answer. 0.54. What is the ratio of the Amount (in current US$) of Togo in 1993 to that in 1994?
Provide a short and direct response. 0.01. What is the ratio of the Amount (in current US$) in Uganda in 1993 to that in 1994?
Your answer should be compact. 1.45. What is the difference between the highest and the second highest Amount (in current US$) of Low & middle income?
Your response must be concise. 2.63e+08. What is the difference between the highest and the second highest Amount (in current US$) in Pakistan?
Offer a terse response. 1.54e+08. What is the difference between the highest and the second highest Amount (in current US$) in Togo?
Your answer should be compact. 5.30e+05. What is the difference between the highest and the second highest Amount (in current US$) in Uganda?
Offer a very short reply. 6.10e+06. What is the difference between the highest and the lowest Amount (in current US$) in Low & middle income?
Your response must be concise. 5.78e+08. What is the difference between the highest and the lowest Amount (in current US$) in Pakistan?
Offer a very short reply. 2.52e+08. What is the difference between the highest and the lowest Amount (in current US$) of Togo?
Make the answer very short. 8.60e+06. What is the difference between the highest and the lowest Amount (in current US$) of Uganda?
Ensure brevity in your answer.  2.67e+07. 